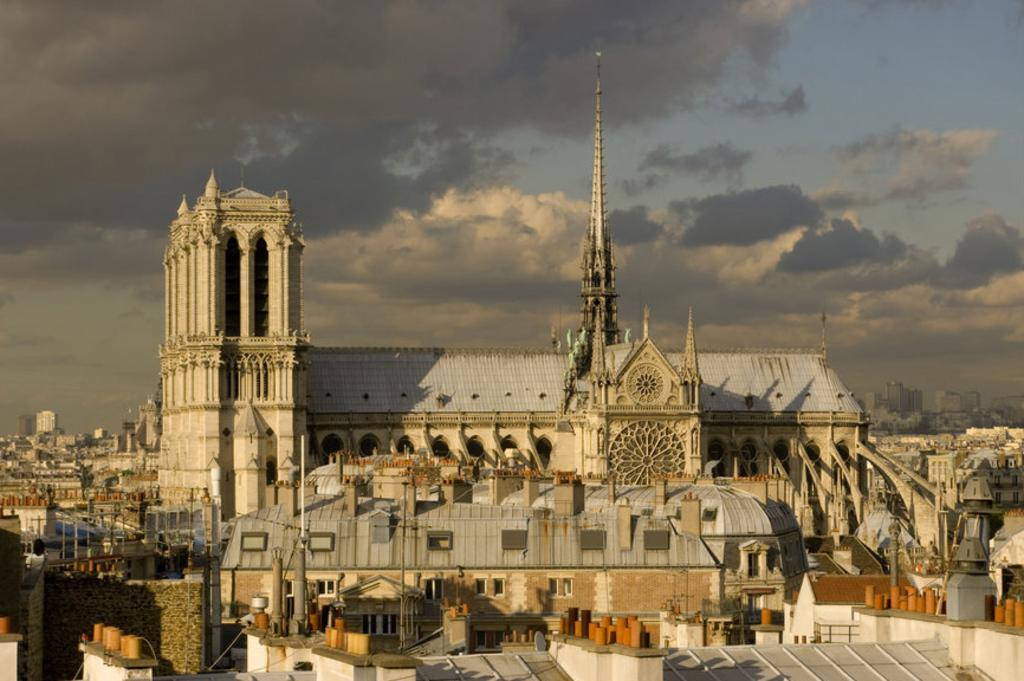What structures can be seen in the image? There are buildings in the image. What can be seen in the sky in the image? There are clouds visible in the background of the image. What type of rock is being used to build the jail in the image? There is no jail present in the image, and therefore no rock being used for construction. 